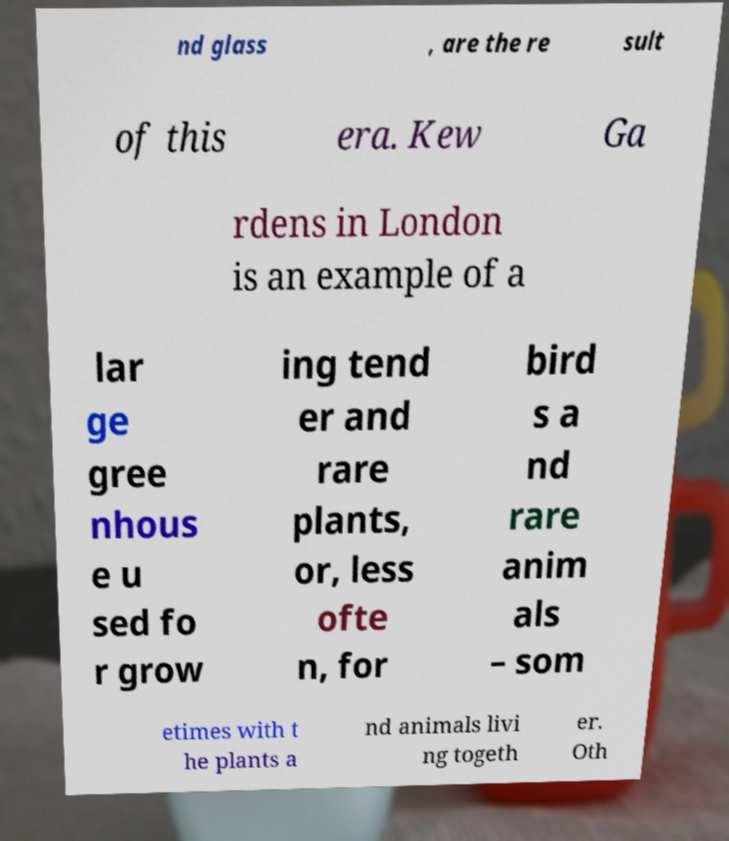Can you read and provide the text displayed in the image?This photo seems to have some interesting text. Can you extract and type it out for me? nd glass , are the re sult of this era. Kew Ga rdens in London is an example of a lar ge gree nhous e u sed fo r grow ing tend er and rare plants, or, less ofte n, for bird s a nd rare anim als – som etimes with t he plants a nd animals livi ng togeth er. Oth 